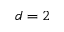Convert formula to latex. <formula><loc_0><loc_0><loc_500><loc_500>d = 2</formula> 